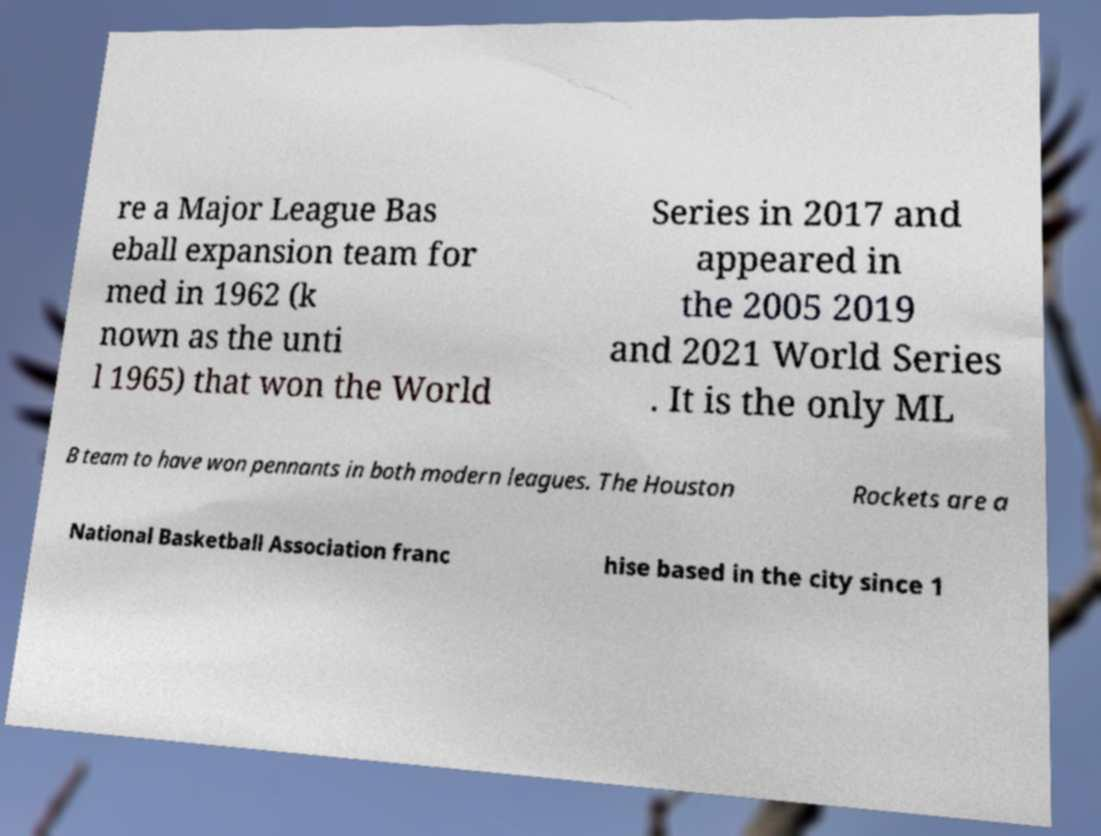Could you assist in decoding the text presented in this image and type it out clearly? re a Major League Bas eball expansion team for med in 1962 (k nown as the unti l 1965) that won the World Series in 2017 and appeared in the 2005 2019 and 2021 World Series . It is the only ML B team to have won pennants in both modern leagues. The Houston Rockets are a National Basketball Association franc hise based in the city since 1 